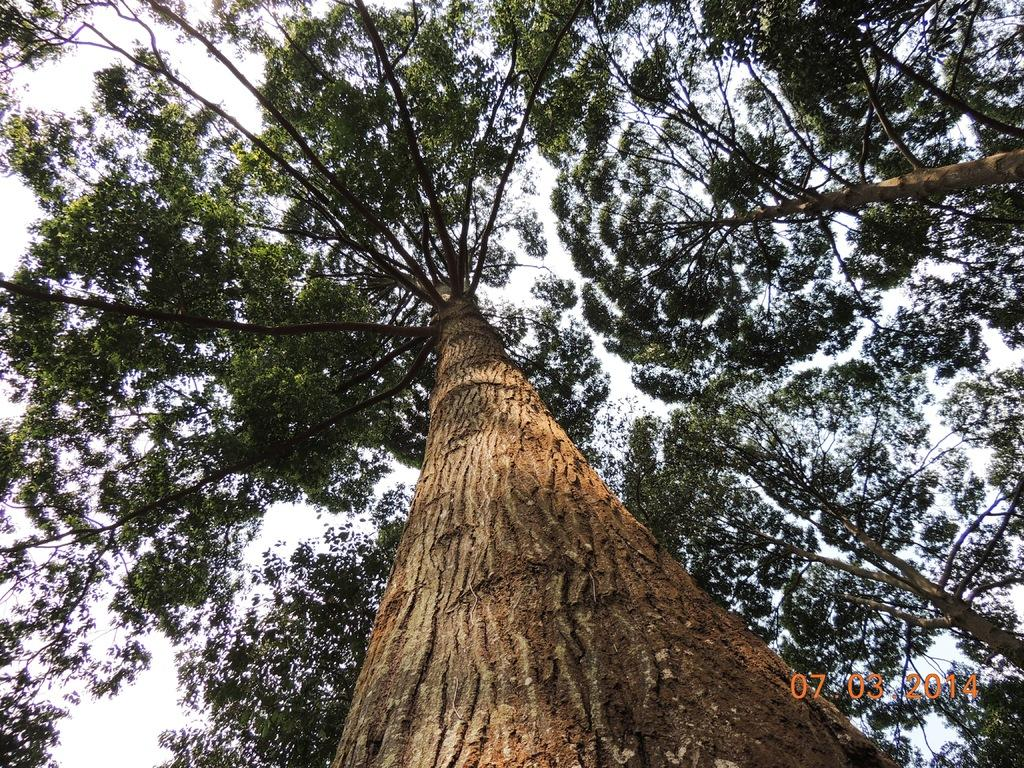What is the main subject in the middle of the image? There is a tree in the middle of the image. Are there any other trees visible in the image? Yes, there are other trees at the right side of the image. What can be seen in the background of the image? The sky is visible in the background of the image. How many men are sitting on the branches of the trees in the image? There are no men present in the image; it only features trees and the sky. 